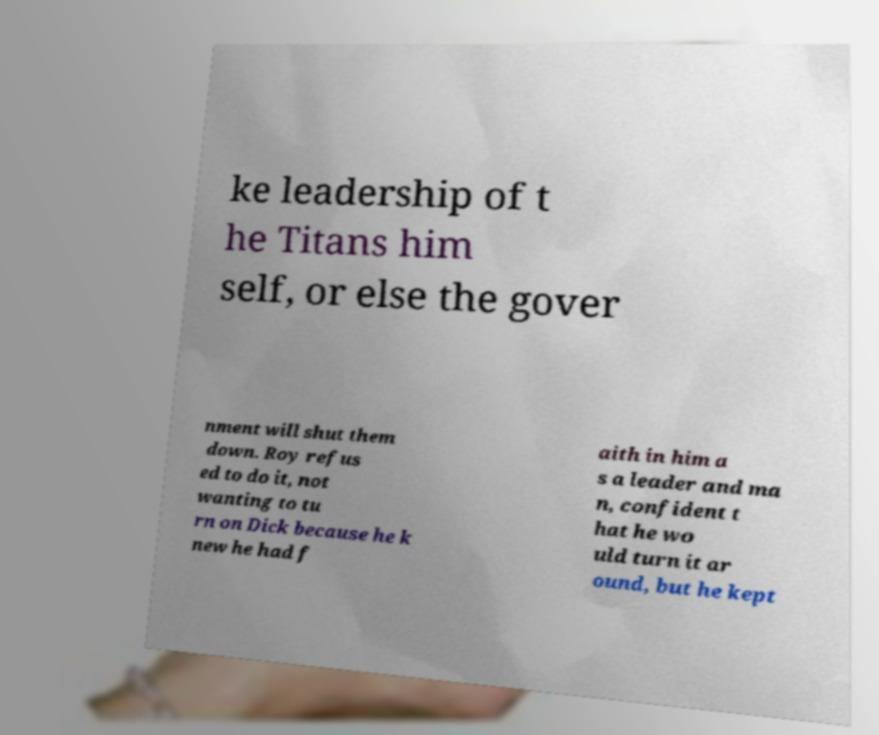Can you accurately transcribe the text from the provided image for me? ke leadership of t he Titans him self, or else the gover nment will shut them down. Roy refus ed to do it, not wanting to tu rn on Dick because he k new he had f aith in him a s a leader and ma n, confident t hat he wo uld turn it ar ound, but he kept 